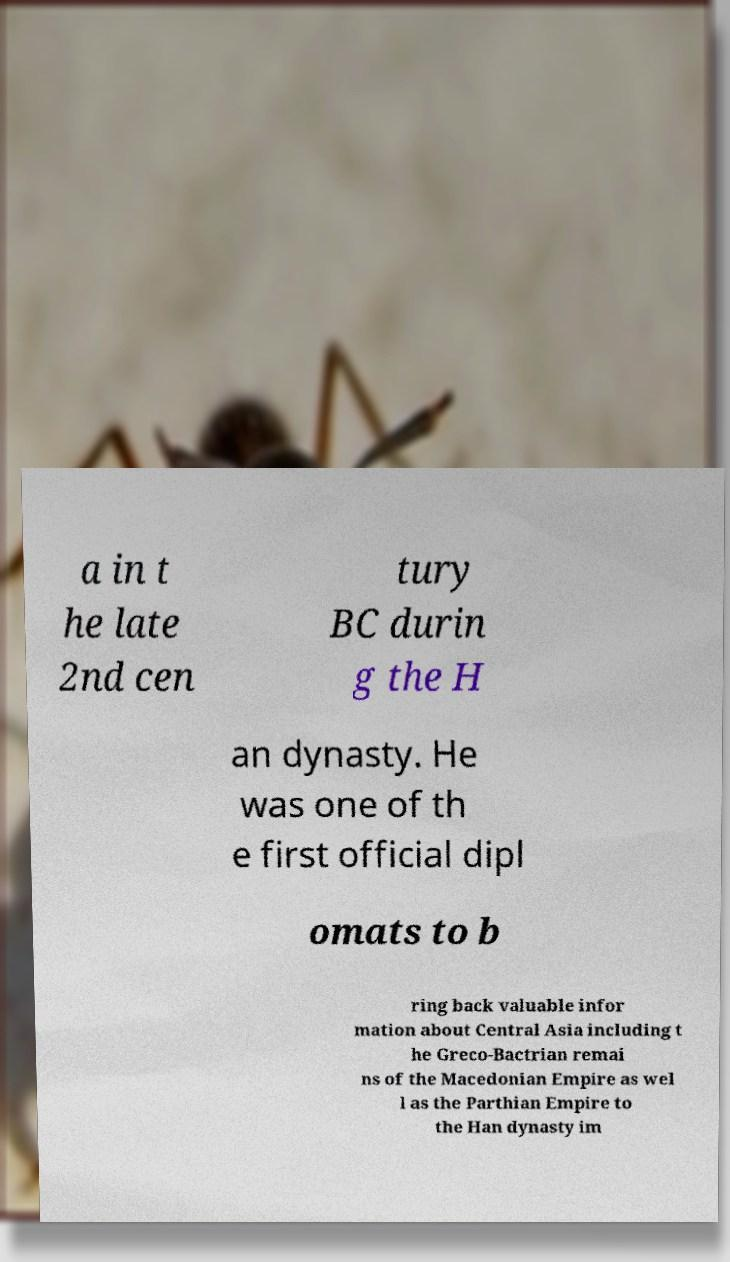Could you extract and type out the text from this image? a in t he late 2nd cen tury BC durin g the H an dynasty. He was one of th e first official dipl omats to b ring back valuable infor mation about Central Asia including t he Greco-Bactrian remai ns of the Macedonian Empire as wel l as the Parthian Empire to the Han dynasty im 